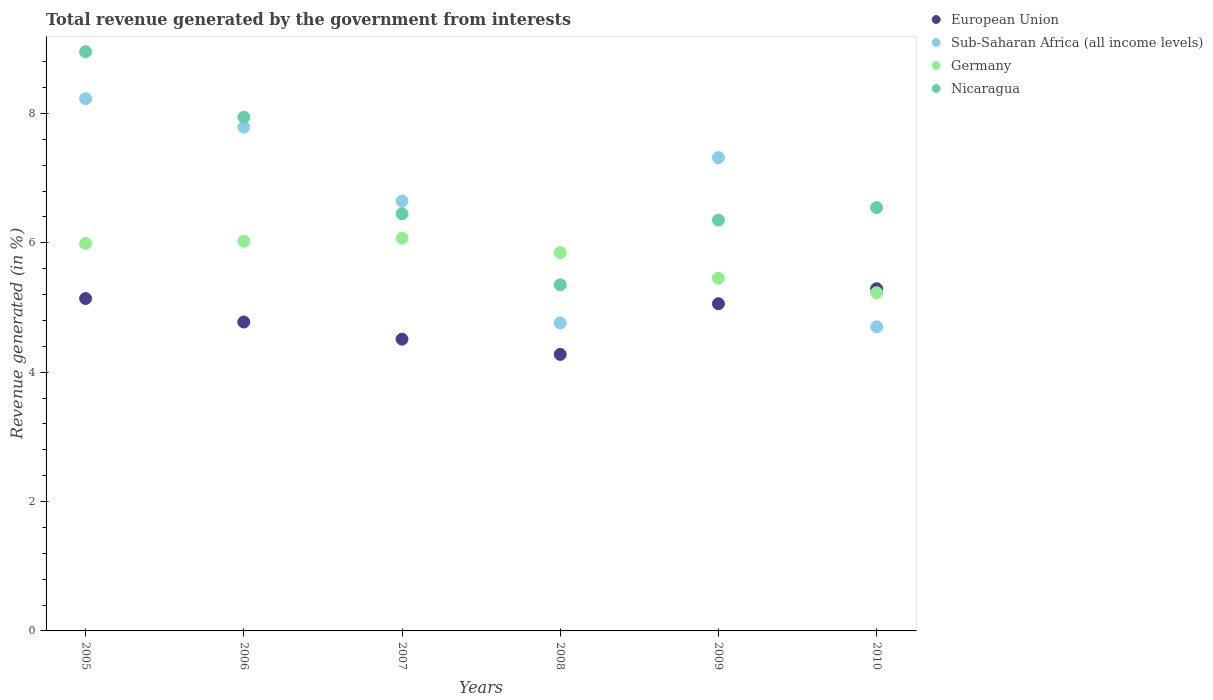How many different coloured dotlines are there?
Make the answer very short. 4. Is the number of dotlines equal to the number of legend labels?
Your response must be concise. Yes. What is the total revenue generated in Sub-Saharan Africa (all income levels) in 2007?
Offer a very short reply. 6.65. Across all years, what is the maximum total revenue generated in Nicaragua?
Provide a succinct answer. 8.96. Across all years, what is the minimum total revenue generated in Germany?
Your response must be concise. 5.23. In which year was the total revenue generated in Sub-Saharan Africa (all income levels) maximum?
Make the answer very short. 2005. In which year was the total revenue generated in Sub-Saharan Africa (all income levels) minimum?
Your answer should be compact. 2010. What is the total total revenue generated in European Union in the graph?
Provide a succinct answer. 29.05. What is the difference between the total revenue generated in Germany in 2005 and that in 2010?
Give a very brief answer. 0.76. What is the difference between the total revenue generated in Germany in 2009 and the total revenue generated in European Union in 2010?
Your answer should be compact. 0.16. What is the average total revenue generated in Sub-Saharan Africa (all income levels) per year?
Make the answer very short. 6.57. In the year 2010, what is the difference between the total revenue generated in Sub-Saharan Africa (all income levels) and total revenue generated in Germany?
Your answer should be compact. -0.53. In how many years, is the total revenue generated in Sub-Saharan Africa (all income levels) greater than 6.8 %?
Give a very brief answer. 3. What is the ratio of the total revenue generated in Sub-Saharan Africa (all income levels) in 2006 to that in 2008?
Provide a succinct answer. 1.64. Is the total revenue generated in European Union in 2005 less than that in 2006?
Your answer should be very brief. No. What is the difference between the highest and the second highest total revenue generated in Germany?
Make the answer very short. 0.05. What is the difference between the highest and the lowest total revenue generated in Germany?
Offer a terse response. 0.84. In how many years, is the total revenue generated in Sub-Saharan Africa (all income levels) greater than the average total revenue generated in Sub-Saharan Africa (all income levels) taken over all years?
Your answer should be very brief. 4. Is the sum of the total revenue generated in Sub-Saharan Africa (all income levels) in 2007 and 2008 greater than the maximum total revenue generated in Nicaragua across all years?
Your answer should be compact. Yes. Is it the case that in every year, the sum of the total revenue generated in Germany and total revenue generated in Sub-Saharan Africa (all income levels)  is greater than the sum of total revenue generated in European Union and total revenue generated in Nicaragua?
Keep it short and to the point. No. Does the total revenue generated in Sub-Saharan Africa (all income levels) monotonically increase over the years?
Offer a terse response. No. How many dotlines are there?
Your answer should be compact. 4. How many years are there in the graph?
Offer a terse response. 6. What is the difference between two consecutive major ticks on the Y-axis?
Keep it short and to the point. 2. Does the graph contain any zero values?
Provide a short and direct response. No. Where does the legend appear in the graph?
Keep it short and to the point. Top right. How many legend labels are there?
Your response must be concise. 4. What is the title of the graph?
Your response must be concise. Total revenue generated by the government from interests. What is the label or title of the Y-axis?
Keep it short and to the point. Revenue generated (in %). What is the Revenue generated (in %) of European Union in 2005?
Offer a very short reply. 5.14. What is the Revenue generated (in %) in Sub-Saharan Africa (all income levels) in 2005?
Make the answer very short. 8.23. What is the Revenue generated (in %) in Germany in 2005?
Provide a short and direct response. 5.99. What is the Revenue generated (in %) of Nicaragua in 2005?
Keep it short and to the point. 8.96. What is the Revenue generated (in %) of European Union in 2006?
Give a very brief answer. 4.78. What is the Revenue generated (in %) of Sub-Saharan Africa (all income levels) in 2006?
Ensure brevity in your answer.  7.79. What is the Revenue generated (in %) of Germany in 2006?
Your response must be concise. 6.03. What is the Revenue generated (in %) in Nicaragua in 2006?
Keep it short and to the point. 7.94. What is the Revenue generated (in %) in European Union in 2007?
Provide a short and direct response. 4.51. What is the Revenue generated (in %) of Sub-Saharan Africa (all income levels) in 2007?
Ensure brevity in your answer.  6.65. What is the Revenue generated (in %) in Germany in 2007?
Provide a short and direct response. 6.07. What is the Revenue generated (in %) in Nicaragua in 2007?
Ensure brevity in your answer.  6.45. What is the Revenue generated (in %) of European Union in 2008?
Provide a succinct answer. 4.28. What is the Revenue generated (in %) in Sub-Saharan Africa (all income levels) in 2008?
Offer a terse response. 4.76. What is the Revenue generated (in %) of Germany in 2008?
Your response must be concise. 5.85. What is the Revenue generated (in %) in Nicaragua in 2008?
Your response must be concise. 5.35. What is the Revenue generated (in %) of European Union in 2009?
Offer a very short reply. 5.06. What is the Revenue generated (in %) in Sub-Saharan Africa (all income levels) in 2009?
Ensure brevity in your answer.  7.32. What is the Revenue generated (in %) of Germany in 2009?
Your answer should be compact. 5.45. What is the Revenue generated (in %) of Nicaragua in 2009?
Keep it short and to the point. 6.35. What is the Revenue generated (in %) of European Union in 2010?
Keep it short and to the point. 5.29. What is the Revenue generated (in %) in Sub-Saharan Africa (all income levels) in 2010?
Offer a very short reply. 4.7. What is the Revenue generated (in %) of Germany in 2010?
Ensure brevity in your answer.  5.23. What is the Revenue generated (in %) in Nicaragua in 2010?
Give a very brief answer. 6.55. Across all years, what is the maximum Revenue generated (in %) in European Union?
Your answer should be very brief. 5.29. Across all years, what is the maximum Revenue generated (in %) in Sub-Saharan Africa (all income levels)?
Provide a succinct answer. 8.23. Across all years, what is the maximum Revenue generated (in %) in Germany?
Offer a terse response. 6.07. Across all years, what is the maximum Revenue generated (in %) of Nicaragua?
Offer a terse response. 8.96. Across all years, what is the minimum Revenue generated (in %) in European Union?
Offer a terse response. 4.28. Across all years, what is the minimum Revenue generated (in %) of Sub-Saharan Africa (all income levels)?
Offer a terse response. 4.7. Across all years, what is the minimum Revenue generated (in %) of Germany?
Provide a succinct answer. 5.23. Across all years, what is the minimum Revenue generated (in %) of Nicaragua?
Make the answer very short. 5.35. What is the total Revenue generated (in %) of European Union in the graph?
Provide a succinct answer. 29.05. What is the total Revenue generated (in %) in Sub-Saharan Africa (all income levels) in the graph?
Offer a terse response. 39.45. What is the total Revenue generated (in %) in Germany in the graph?
Give a very brief answer. 34.62. What is the total Revenue generated (in %) of Nicaragua in the graph?
Offer a terse response. 41.6. What is the difference between the Revenue generated (in %) in European Union in 2005 and that in 2006?
Make the answer very short. 0.36. What is the difference between the Revenue generated (in %) in Sub-Saharan Africa (all income levels) in 2005 and that in 2006?
Your response must be concise. 0.44. What is the difference between the Revenue generated (in %) of Germany in 2005 and that in 2006?
Ensure brevity in your answer.  -0.03. What is the difference between the Revenue generated (in %) in Nicaragua in 2005 and that in 2006?
Keep it short and to the point. 1.01. What is the difference between the Revenue generated (in %) of European Union in 2005 and that in 2007?
Provide a succinct answer. 0.63. What is the difference between the Revenue generated (in %) in Sub-Saharan Africa (all income levels) in 2005 and that in 2007?
Offer a terse response. 1.58. What is the difference between the Revenue generated (in %) in Germany in 2005 and that in 2007?
Offer a terse response. -0.08. What is the difference between the Revenue generated (in %) in Nicaragua in 2005 and that in 2007?
Offer a terse response. 2.5. What is the difference between the Revenue generated (in %) in European Union in 2005 and that in 2008?
Ensure brevity in your answer.  0.86. What is the difference between the Revenue generated (in %) in Sub-Saharan Africa (all income levels) in 2005 and that in 2008?
Provide a short and direct response. 3.47. What is the difference between the Revenue generated (in %) in Germany in 2005 and that in 2008?
Ensure brevity in your answer.  0.14. What is the difference between the Revenue generated (in %) of Nicaragua in 2005 and that in 2008?
Ensure brevity in your answer.  3.6. What is the difference between the Revenue generated (in %) of European Union in 2005 and that in 2009?
Your answer should be very brief. 0.08. What is the difference between the Revenue generated (in %) of Sub-Saharan Africa (all income levels) in 2005 and that in 2009?
Your answer should be compact. 0.91. What is the difference between the Revenue generated (in %) of Germany in 2005 and that in 2009?
Provide a succinct answer. 0.54. What is the difference between the Revenue generated (in %) in Nicaragua in 2005 and that in 2009?
Provide a short and direct response. 2.6. What is the difference between the Revenue generated (in %) of European Union in 2005 and that in 2010?
Keep it short and to the point. -0.15. What is the difference between the Revenue generated (in %) in Sub-Saharan Africa (all income levels) in 2005 and that in 2010?
Provide a short and direct response. 3.53. What is the difference between the Revenue generated (in %) in Germany in 2005 and that in 2010?
Make the answer very short. 0.76. What is the difference between the Revenue generated (in %) in Nicaragua in 2005 and that in 2010?
Offer a very short reply. 2.41. What is the difference between the Revenue generated (in %) in European Union in 2006 and that in 2007?
Offer a terse response. 0.27. What is the difference between the Revenue generated (in %) of Sub-Saharan Africa (all income levels) in 2006 and that in 2007?
Keep it short and to the point. 1.14. What is the difference between the Revenue generated (in %) in Germany in 2006 and that in 2007?
Your answer should be compact. -0.05. What is the difference between the Revenue generated (in %) of Nicaragua in 2006 and that in 2007?
Ensure brevity in your answer.  1.49. What is the difference between the Revenue generated (in %) in European Union in 2006 and that in 2008?
Your response must be concise. 0.5. What is the difference between the Revenue generated (in %) in Sub-Saharan Africa (all income levels) in 2006 and that in 2008?
Provide a short and direct response. 3.03. What is the difference between the Revenue generated (in %) in Germany in 2006 and that in 2008?
Offer a terse response. 0.18. What is the difference between the Revenue generated (in %) of Nicaragua in 2006 and that in 2008?
Give a very brief answer. 2.59. What is the difference between the Revenue generated (in %) of European Union in 2006 and that in 2009?
Provide a short and direct response. -0.28. What is the difference between the Revenue generated (in %) of Sub-Saharan Africa (all income levels) in 2006 and that in 2009?
Keep it short and to the point. 0.47. What is the difference between the Revenue generated (in %) in Germany in 2006 and that in 2009?
Your response must be concise. 0.57. What is the difference between the Revenue generated (in %) of Nicaragua in 2006 and that in 2009?
Provide a short and direct response. 1.59. What is the difference between the Revenue generated (in %) in European Union in 2006 and that in 2010?
Give a very brief answer. -0.51. What is the difference between the Revenue generated (in %) in Sub-Saharan Africa (all income levels) in 2006 and that in 2010?
Offer a terse response. 3.09. What is the difference between the Revenue generated (in %) in Germany in 2006 and that in 2010?
Offer a terse response. 0.8. What is the difference between the Revenue generated (in %) of Nicaragua in 2006 and that in 2010?
Offer a very short reply. 1.4. What is the difference between the Revenue generated (in %) of European Union in 2007 and that in 2008?
Make the answer very short. 0.24. What is the difference between the Revenue generated (in %) of Sub-Saharan Africa (all income levels) in 2007 and that in 2008?
Keep it short and to the point. 1.88. What is the difference between the Revenue generated (in %) of Germany in 2007 and that in 2008?
Your answer should be very brief. 0.22. What is the difference between the Revenue generated (in %) in Nicaragua in 2007 and that in 2008?
Your answer should be very brief. 1.1. What is the difference between the Revenue generated (in %) in European Union in 2007 and that in 2009?
Ensure brevity in your answer.  -0.55. What is the difference between the Revenue generated (in %) in Sub-Saharan Africa (all income levels) in 2007 and that in 2009?
Provide a short and direct response. -0.67. What is the difference between the Revenue generated (in %) of Germany in 2007 and that in 2009?
Your response must be concise. 0.62. What is the difference between the Revenue generated (in %) in Nicaragua in 2007 and that in 2009?
Keep it short and to the point. 0.1. What is the difference between the Revenue generated (in %) of European Union in 2007 and that in 2010?
Your answer should be compact. -0.78. What is the difference between the Revenue generated (in %) in Sub-Saharan Africa (all income levels) in 2007 and that in 2010?
Your answer should be compact. 1.95. What is the difference between the Revenue generated (in %) in Germany in 2007 and that in 2010?
Give a very brief answer. 0.84. What is the difference between the Revenue generated (in %) of Nicaragua in 2007 and that in 2010?
Make the answer very short. -0.1. What is the difference between the Revenue generated (in %) in European Union in 2008 and that in 2009?
Give a very brief answer. -0.78. What is the difference between the Revenue generated (in %) in Sub-Saharan Africa (all income levels) in 2008 and that in 2009?
Your answer should be very brief. -2.56. What is the difference between the Revenue generated (in %) in Germany in 2008 and that in 2009?
Your answer should be very brief. 0.4. What is the difference between the Revenue generated (in %) in Nicaragua in 2008 and that in 2009?
Make the answer very short. -1. What is the difference between the Revenue generated (in %) of European Union in 2008 and that in 2010?
Keep it short and to the point. -1.01. What is the difference between the Revenue generated (in %) of Sub-Saharan Africa (all income levels) in 2008 and that in 2010?
Offer a terse response. 0.06. What is the difference between the Revenue generated (in %) in Germany in 2008 and that in 2010?
Make the answer very short. 0.62. What is the difference between the Revenue generated (in %) in Nicaragua in 2008 and that in 2010?
Provide a succinct answer. -1.19. What is the difference between the Revenue generated (in %) in European Union in 2009 and that in 2010?
Provide a short and direct response. -0.23. What is the difference between the Revenue generated (in %) of Sub-Saharan Africa (all income levels) in 2009 and that in 2010?
Provide a short and direct response. 2.62. What is the difference between the Revenue generated (in %) in Germany in 2009 and that in 2010?
Offer a terse response. 0.22. What is the difference between the Revenue generated (in %) in Nicaragua in 2009 and that in 2010?
Offer a very short reply. -0.19. What is the difference between the Revenue generated (in %) of European Union in 2005 and the Revenue generated (in %) of Sub-Saharan Africa (all income levels) in 2006?
Keep it short and to the point. -2.65. What is the difference between the Revenue generated (in %) of European Union in 2005 and the Revenue generated (in %) of Germany in 2006?
Your answer should be compact. -0.89. What is the difference between the Revenue generated (in %) of European Union in 2005 and the Revenue generated (in %) of Nicaragua in 2006?
Provide a succinct answer. -2.8. What is the difference between the Revenue generated (in %) of Sub-Saharan Africa (all income levels) in 2005 and the Revenue generated (in %) of Germany in 2006?
Ensure brevity in your answer.  2.2. What is the difference between the Revenue generated (in %) of Sub-Saharan Africa (all income levels) in 2005 and the Revenue generated (in %) of Nicaragua in 2006?
Make the answer very short. 0.29. What is the difference between the Revenue generated (in %) of Germany in 2005 and the Revenue generated (in %) of Nicaragua in 2006?
Your answer should be compact. -1.95. What is the difference between the Revenue generated (in %) in European Union in 2005 and the Revenue generated (in %) in Sub-Saharan Africa (all income levels) in 2007?
Your answer should be compact. -1.51. What is the difference between the Revenue generated (in %) in European Union in 2005 and the Revenue generated (in %) in Germany in 2007?
Keep it short and to the point. -0.93. What is the difference between the Revenue generated (in %) of European Union in 2005 and the Revenue generated (in %) of Nicaragua in 2007?
Provide a short and direct response. -1.31. What is the difference between the Revenue generated (in %) of Sub-Saharan Africa (all income levels) in 2005 and the Revenue generated (in %) of Germany in 2007?
Make the answer very short. 2.16. What is the difference between the Revenue generated (in %) of Sub-Saharan Africa (all income levels) in 2005 and the Revenue generated (in %) of Nicaragua in 2007?
Offer a very short reply. 1.78. What is the difference between the Revenue generated (in %) in Germany in 2005 and the Revenue generated (in %) in Nicaragua in 2007?
Offer a very short reply. -0.46. What is the difference between the Revenue generated (in %) of European Union in 2005 and the Revenue generated (in %) of Sub-Saharan Africa (all income levels) in 2008?
Offer a terse response. 0.38. What is the difference between the Revenue generated (in %) of European Union in 2005 and the Revenue generated (in %) of Germany in 2008?
Offer a terse response. -0.71. What is the difference between the Revenue generated (in %) in European Union in 2005 and the Revenue generated (in %) in Nicaragua in 2008?
Ensure brevity in your answer.  -0.21. What is the difference between the Revenue generated (in %) of Sub-Saharan Africa (all income levels) in 2005 and the Revenue generated (in %) of Germany in 2008?
Make the answer very short. 2.38. What is the difference between the Revenue generated (in %) in Sub-Saharan Africa (all income levels) in 2005 and the Revenue generated (in %) in Nicaragua in 2008?
Provide a short and direct response. 2.88. What is the difference between the Revenue generated (in %) of Germany in 2005 and the Revenue generated (in %) of Nicaragua in 2008?
Offer a very short reply. 0.64. What is the difference between the Revenue generated (in %) in European Union in 2005 and the Revenue generated (in %) in Sub-Saharan Africa (all income levels) in 2009?
Make the answer very short. -2.18. What is the difference between the Revenue generated (in %) of European Union in 2005 and the Revenue generated (in %) of Germany in 2009?
Your answer should be compact. -0.31. What is the difference between the Revenue generated (in %) of European Union in 2005 and the Revenue generated (in %) of Nicaragua in 2009?
Offer a very short reply. -1.21. What is the difference between the Revenue generated (in %) in Sub-Saharan Africa (all income levels) in 2005 and the Revenue generated (in %) in Germany in 2009?
Offer a very short reply. 2.78. What is the difference between the Revenue generated (in %) of Sub-Saharan Africa (all income levels) in 2005 and the Revenue generated (in %) of Nicaragua in 2009?
Make the answer very short. 1.88. What is the difference between the Revenue generated (in %) of Germany in 2005 and the Revenue generated (in %) of Nicaragua in 2009?
Offer a terse response. -0.36. What is the difference between the Revenue generated (in %) in European Union in 2005 and the Revenue generated (in %) in Sub-Saharan Africa (all income levels) in 2010?
Provide a succinct answer. 0.44. What is the difference between the Revenue generated (in %) of European Union in 2005 and the Revenue generated (in %) of Germany in 2010?
Ensure brevity in your answer.  -0.09. What is the difference between the Revenue generated (in %) of European Union in 2005 and the Revenue generated (in %) of Nicaragua in 2010?
Provide a succinct answer. -1.41. What is the difference between the Revenue generated (in %) of Sub-Saharan Africa (all income levels) in 2005 and the Revenue generated (in %) of Germany in 2010?
Keep it short and to the point. 3. What is the difference between the Revenue generated (in %) in Sub-Saharan Africa (all income levels) in 2005 and the Revenue generated (in %) in Nicaragua in 2010?
Provide a succinct answer. 1.68. What is the difference between the Revenue generated (in %) in Germany in 2005 and the Revenue generated (in %) in Nicaragua in 2010?
Your response must be concise. -0.56. What is the difference between the Revenue generated (in %) of European Union in 2006 and the Revenue generated (in %) of Sub-Saharan Africa (all income levels) in 2007?
Provide a short and direct response. -1.87. What is the difference between the Revenue generated (in %) of European Union in 2006 and the Revenue generated (in %) of Germany in 2007?
Keep it short and to the point. -1.3. What is the difference between the Revenue generated (in %) in European Union in 2006 and the Revenue generated (in %) in Nicaragua in 2007?
Offer a very short reply. -1.67. What is the difference between the Revenue generated (in %) in Sub-Saharan Africa (all income levels) in 2006 and the Revenue generated (in %) in Germany in 2007?
Provide a succinct answer. 1.72. What is the difference between the Revenue generated (in %) of Sub-Saharan Africa (all income levels) in 2006 and the Revenue generated (in %) of Nicaragua in 2007?
Your answer should be compact. 1.34. What is the difference between the Revenue generated (in %) in Germany in 2006 and the Revenue generated (in %) in Nicaragua in 2007?
Make the answer very short. -0.43. What is the difference between the Revenue generated (in %) in European Union in 2006 and the Revenue generated (in %) in Sub-Saharan Africa (all income levels) in 2008?
Make the answer very short. 0.01. What is the difference between the Revenue generated (in %) of European Union in 2006 and the Revenue generated (in %) of Germany in 2008?
Give a very brief answer. -1.07. What is the difference between the Revenue generated (in %) of European Union in 2006 and the Revenue generated (in %) of Nicaragua in 2008?
Make the answer very short. -0.58. What is the difference between the Revenue generated (in %) of Sub-Saharan Africa (all income levels) in 2006 and the Revenue generated (in %) of Germany in 2008?
Your answer should be very brief. 1.94. What is the difference between the Revenue generated (in %) in Sub-Saharan Africa (all income levels) in 2006 and the Revenue generated (in %) in Nicaragua in 2008?
Keep it short and to the point. 2.44. What is the difference between the Revenue generated (in %) in Germany in 2006 and the Revenue generated (in %) in Nicaragua in 2008?
Offer a terse response. 0.67. What is the difference between the Revenue generated (in %) of European Union in 2006 and the Revenue generated (in %) of Sub-Saharan Africa (all income levels) in 2009?
Your answer should be compact. -2.54. What is the difference between the Revenue generated (in %) of European Union in 2006 and the Revenue generated (in %) of Germany in 2009?
Offer a very short reply. -0.68. What is the difference between the Revenue generated (in %) in European Union in 2006 and the Revenue generated (in %) in Nicaragua in 2009?
Give a very brief answer. -1.58. What is the difference between the Revenue generated (in %) in Sub-Saharan Africa (all income levels) in 2006 and the Revenue generated (in %) in Germany in 2009?
Provide a short and direct response. 2.33. What is the difference between the Revenue generated (in %) in Sub-Saharan Africa (all income levels) in 2006 and the Revenue generated (in %) in Nicaragua in 2009?
Ensure brevity in your answer.  1.44. What is the difference between the Revenue generated (in %) of Germany in 2006 and the Revenue generated (in %) of Nicaragua in 2009?
Your answer should be very brief. -0.33. What is the difference between the Revenue generated (in %) of European Union in 2006 and the Revenue generated (in %) of Sub-Saharan Africa (all income levels) in 2010?
Your response must be concise. 0.07. What is the difference between the Revenue generated (in %) of European Union in 2006 and the Revenue generated (in %) of Germany in 2010?
Give a very brief answer. -0.45. What is the difference between the Revenue generated (in %) of European Union in 2006 and the Revenue generated (in %) of Nicaragua in 2010?
Your response must be concise. -1.77. What is the difference between the Revenue generated (in %) in Sub-Saharan Africa (all income levels) in 2006 and the Revenue generated (in %) in Germany in 2010?
Offer a terse response. 2.56. What is the difference between the Revenue generated (in %) in Sub-Saharan Africa (all income levels) in 2006 and the Revenue generated (in %) in Nicaragua in 2010?
Offer a terse response. 1.24. What is the difference between the Revenue generated (in %) of Germany in 2006 and the Revenue generated (in %) of Nicaragua in 2010?
Offer a very short reply. -0.52. What is the difference between the Revenue generated (in %) in European Union in 2007 and the Revenue generated (in %) in Sub-Saharan Africa (all income levels) in 2008?
Provide a short and direct response. -0.25. What is the difference between the Revenue generated (in %) in European Union in 2007 and the Revenue generated (in %) in Germany in 2008?
Make the answer very short. -1.34. What is the difference between the Revenue generated (in %) of European Union in 2007 and the Revenue generated (in %) of Nicaragua in 2008?
Ensure brevity in your answer.  -0.84. What is the difference between the Revenue generated (in %) in Sub-Saharan Africa (all income levels) in 2007 and the Revenue generated (in %) in Germany in 2008?
Give a very brief answer. 0.8. What is the difference between the Revenue generated (in %) in Sub-Saharan Africa (all income levels) in 2007 and the Revenue generated (in %) in Nicaragua in 2008?
Ensure brevity in your answer.  1.29. What is the difference between the Revenue generated (in %) of Germany in 2007 and the Revenue generated (in %) of Nicaragua in 2008?
Make the answer very short. 0.72. What is the difference between the Revenue generated (in %) in European Union in 2007 and the Revenue generated (in %) in Sub-Saharan Africa (all income levels) in 2009?
Your answer should be compact. -2.81. What is the difference between the Revenue generated (in %) in European Union in 2007 and the Revenue generated (in %) in Germany in 2009?
Ensure brevity in your answer.  -0.94. What is the difference between the Revenue generated (in %) of European Union in 2007 and the Revenue generated (in %) of Nicaragua in 2009?
Give a very brief answer. -1.84. What is the difference between the Revenue generated (in %) in Sub-Saharan Africa (all income levels) in 2007 and the Revenue generated (in %) in Germany in 2009?
Offer a very short reply. 1.19. What is the difference between the Revenue generated (in %) in Sub-Saharan Africa (all income levels) in 2007 and the Revenue generated (in %) in Nicaragua in 2009?
Provide a short and direct response. 0.29. What is the difference between the Revenue generated (in %) of Germany in 2007 and the Revenue generated (in %) of Nicaragua in 2009?
Make the answer very short. -0.28. What is the difference between the Revenue generated (in %) in European Union in 2007 and the Revenue generated (in %) in Sub-Saharan Africa (all income levels) in 2010?
Your answer should be compact. -0.19. What is the difference between the Revenue generated (in %) of European Union in 2007 and the Revenue generated (in %) of Germany in 2010?
Keep it short and to the point. -0.72. What is the difference between the Revenue generated (in %) in European Union in 2007 and the Revenue generated (in %) in Nicaragua in 2010?
Offer a very short reply. -2.04. What is the difference between the Revenue generated (in %) in Sub-Saharan Africa (all income levels) in 2007 and the Revenue generated (in %) in Germany in 2010?
Provide a succinct answer. 1.42. What is the difference between the Revenue generated (in %) in Sub-Saharan Africa (all income levels) in 2007 and the Revenue generated (in %) in Nicaragua in 2010?
Make the answer very short. 0.1. What is the difference between the Revenue generated (in %) of Germany in 2007 and the Revenue generated (in %) of Nicaragua in 2010?
Your answer should be very brief. -0.47. What is the difference between the Revenue generated (in %) in European Union in 2008 and the Revenue generated (in %) in Sub-Saharan Africa (all income levels) in 2009?
Your response must be concise. -3.04. What is the difference between the Revenue generated (in %) in European Union in 2008 and the Revenue generated (in %) in Germany in 2009?
Provide a succinct answer. -1.18. What is the difference between the Revenue generated (in %) of European Union in 2008 and the Revenue generated (in %) of Nicaragua in 2009?
Provide a succinct answer. -2.08. What is the difference between the Revenue generated (in %) in Sub-Saharan Africa (all income levels) in 2008 and the Revenue generated (in %) in Germany in 2009?
Make the answer very short. -0.69. What is the difference between the Revenue generated (in %) in Sub-Saharan Africa (all income levels) in 2008 and the Revenue generated (in %) in Nicaragua in 2009?
Provide a succinct answer. -1.59. What is the difference between the Revenue generated (in %) in Germany in 2008 and the Revenue generated (in %) in Nicaragua in 2009?
Offer a very short reply. -0.5. What is the difference between the Revenue generated (in %) in European Union in 2008 and the Revenue generated (in %) in Sub-Saharan Africa (all income levels) in 2010?
Offer a very short reply. -0.43. What is the difference between the Revenue generated (in %) of European Union in 2008 and the Revenue generated (in %) of Germany in 2010?
Provide a short and direct response. -0.95. What is the difference between the Revenue generated (in %) of European Union in 2008 and the Revenue generated (in %) of Nicaragua in 2010?
Ensure brevity in your answer.  -2.27. What is the difference between the Revenue generated (in %) of Sub-Saharan Africa (all income levels) in 2008 and the Revenue generated (in %) of Germany in 2010?
Keep it short and to the point. -0.47. What is the difference between the Revenue generated (in %) of Sub-Saharan Africa (all income levels) in 2008 and the Revenue generated (in %) of Nicaragua in 2010?
Provide a succinct answer. -1.78. What is the difference between the Revenue generated (in %) in Germany in 2008 and the Revenue generated (in %) in Nicaragua in 2010?
Your answer should be very brief. -0.7. What is the difference between the Revenue generated (in %) in European Union in 2009 and the Revenue generated (in %) in Sub-Saharan Africa (all income levels) in 2010?
Provide a short and direct response. 0.36. What is the difference between the Revenue generated (in %) of European Union in 2009 and the Revenue generated (in %) of Germany in 2010?
Give a very brief answer. -0.17. What is the difference between the Revenue generated (in %) of European Union in 2009 and the Revenue generated (in %) of Nicaragua in 2010?
Your answer should be compact. -1.49. What is the difference between the Revenue generated (in %) of Sub-Saharan Africa (all income levels) in 2009 and the Revenue generated (in %) of Germany in 2010?
Offer a terse response. 2.09. What is the difference between the Revenue generated (in %) in Sub-Saharan Africa (all income levels) in 2009 and the Revenue generated (in %) in Nicaragua in 2010?
Keep it short and to the point. 0.77. What is the difference between the Revenue generated (in %) of Germany in 2009 and the Revenue generated (in %) of Nicaragua in 2010?
Ensure brevity in your answer.  -1.09. What is the average Revenue generated (in %) of European Union per year?
Provide a succinct answer. 4.84. What is the average Revenue generated (in %) in Sub-Saharan Africa (all income levels) per year?
Ensure brevity in your answer.  6.57. What is the average Revenue generated (in %) in Germany per year?
Your answer should be compact. 5.77. What is the average Revenue generated (in %) of Nicaragua per year?
Keep it short and to the point. 6.93. In the year 2005, what is the difference between the Revenue generated (in %) of European Union and Revenue generated (in %) of Sub-Saharan Africa (all income levels)?
Ensure brevity in your answer.  -3.09. In the year 2005, what is the difference between the Revenue generated (in %) of European Union and Revenue generated (in %) of Germany?
Provide a succinct answer. -0.85. In the year 2005, what is the difference between the Revenue generated (in %) of European Union and Revenue generated (in %) of Nicaragua?
Your answer should be very brief. -3.82. In the year 2005, what is the difference between the Revenue generated (in %) in Sub-Saharan Africa (all income levels) and Revenue generated (in %) in Germany?
Your response must be concise. 2.24. In the year 2005, what is the difference between the Revenue generated (in %) in Sub-Saharan Africa (all income levels) and Revenue generated (in %) in Nicaragua?
Offer a terse response. -0.73. In the year 2005, what is the difference between the Revenue generated (in %) of Germany and Revenue generated (in %) of Nicaragua?
Ensure brevity in your answer.  -2.96. In the year 2006, what is the difference between the Revenue generated (in %) of European Union and Revenue generated (in %) of Sub-Saharan Africa (all income levels)?
Offer a very short reply. -3.01. In the year 2006, what is the difference between the Revenue generated (in %) of European Union and Revenue generated (in %) of Germany?
Provide a short and direct response. -1.25. In the year 2006, what is the difference between the Revenue generated (in %) of European Union and Revenue generated (in %) of Nicaragua?
Offer a very short reply. -3.17. In the year 2006, what is the difference between the Revenue generated (in %) in Sub-Saharan Africa (all income levels) and Revenue generated (in %) in Germany?
Provide a short and direct response. 1.76. In the year 2006, what is the difference between the Revenue generated (in %) of Sub-Saharan Africa (all income levels) and Revenue generated (in %) of Nicaragua?
Make the answer very short. -0.15. In the year 2006, what is the difference between the Revenue generated (in %) of Germany and Revenue generated (in %) of Nicaragua?
Your answer should be compact. -1.92. In the year 2007, what is the difference between the Revenue generated (in %) of European Union and Revenue generated (in %) of Sub-Saharan Africa (all income levels)?
Provide a succinct answer. -2.14. In the year 2007, what is the difference between the Revenue generated (in %) of European Union and Revenue generated (in %) of Germany?
Provide a short and direct response. -1.56. In the year 2007, what is the difference between the Revenue generated (in %) in European Union and Revenue generated (in %) in Nicaragua?
Provide a succinct answer. -1.94. In the year 2007, what is the difference between the Revenue generated (in %) in Sub-Saharan Africa (all income levels) and Revenue generated (in %) in Germany?
Give a very brief answer. 0.57. In the year 2007, what is the difference between the Revenue generated (in %) of Sub-Saharan Africa (all income levels) and Revenue generated (in %) of Nicaragua?
Offer a very short reply. 0.2. In the year 2007, what is the difference between the Revenue generated (in %) in Germany and Revenue generated (in %) in Nicaragua?
Your response must be concise. -0.38. In the year 2008, what is the difference between the Revenue generated (in %) of European Union and Revenue generated (in %) of Sub-Saharan Africa (all income levels)?
Offer a very short reply. -0.49. In the year 2008, what is the difference between the Revenue generated (in %) in European Union and Revenue generated (in %) in Germany?
Your answer should be compact. -1.57. In the year 2008, what is the difference between the Revenue generated (in %) in European Union and Revenue generated (in %) in Nicaragua?
Offer a terse response. -1.08. In the year 2008, what is the difference between the Revenue generated (in %) in Sub-Saharan Africa (all income levels) and Revenue generated (in %) in Germany?
Offer a terse response. -1.09. In the year 2008, what is the difference between the Revenue generated (in %) in Sub-Saharan Africa (all income levels) and Revenue generated (in %) in Nicaragua?
Provide a short and direct response. -0.59. In the year 2008, what is the difference between the Revenue generated (in %) of Germany and Revenue generated (in %) of Nicaragua?
Give a very brief answer. 0.5. In the year 2009, what is the difference between the Revenue generated (in %) of European Union and Revenue generated (in %) of Sub-Saharan Africa (all income levels)?
Give a very brief answer. -2.26. In the year 2009, what is the difference between the Revenue generated (in %) in European Union and Revenue generated (in %) in Germany?
Provide a succinct answer. -0.39. In the year 2009, what is the difference between the Revenue generated (in %) in European Union and Revenue generated (in %) in Nicaragua?
Offer a very short reply. -1.29. In the year 2009, what is the difference between the Revenue generated (in %) of Sub-Saharan Africa (all income levels) and Revenue generated (in %) of Germany?
Provide a succinct answer. 1.86. In the year 2009, what is the difference between the Revenue generated (in %) in Sub-Saharan Africa (all income levels) and Revenue generated (in %) in Nicaragua?
Your answer should be very brief. 0.97. In the year 2009, what is the difference between the Revenue generated (in %) in Germany and Revenue generated (in %) in Nicaragua?
Give a very brief answer. -0.9. In the year 2010, what is the difference between the Revenue generated (in %) in European Union and Revenue generated (in %) in Sub-Saharan Africa (all income levels)?
Offer a very short reply. 0.59. In the year 2010, what is the difference between the Revenue generated (in %) of European Union and Revenue generated (in %) of Germany?
Ensure brevity in your answer.  0.06. In the year 2010, what is the difference between the Revenue generated (in %) in European Union and Revenue generated (in %) in Nicaragua?
Offer a terse response. -1.26. In the year 2010, what is the difference between the Revenue generated (in %) of Sub-Saharan Africa (all income levels) and Revenue generated (in %) of Germany?
Give a very brief answer. -0.53. In the year 2010, what is the difference between the Revenue generated (in %) in Sub-Saharan Africa (all income levels) and Revenue generated (in %) in Nicaragua?
Give a very brief answer. -1.84. In the year 2010, what is the difference between the Revenue generated (in %) of Germany and Revenue generated (in %) of Nicaragua?
Provide a short and direct response. -1.32. What is the ratio of the Revenue generated (in %) of European Union in 2005 to that in 2006?
Keep it short and to the point. 1.08. What is the ratio of the Revenue generated (in %) of Sub-Saharan Africa (all income levels) in 2005 to that in 2006?
Provide a succinct answer. 1.06. What is the ratio of the Revenue generated (in %) in Germany in 2005 to that in 2006?
Ensure brevity in your answer.  0.99. What is the ratio of the Revenue generated (in %) of Nicaragua in 2005 to that in 2006?
Offer a very short reply. 1.13. What is the ratio of the Revenue generated (in %) in European Union in 2005 to that in 2007?
Your answer should be compact. 1.14. What is the ratio of the Revenue generated (in %) of Sub-Saharan Africa (all income levels) in 2005 to that in 2007?
Offer a terse response. 1.24. What is the ratio of the Revenue generated (in %) in Germany in 2005 to that in 2007?
Make the answer very short. 0.99. What is the ratio of the Revenue generated (in %) of Nicaragua in 2005 to that in 2007?
Your answer should be very brief. 1.39. What is the ratio of the Revenue generated (in %) in European Union in 2005 to that in 2008?
Your response must be concise. 1.2. What is the ratio of the Revenue generated (in %) in Sub-Saharan Africa (all income levels) in 2005 to that in 2008?
Your response must be concise. 1.73. What is the ratio of the Revenue generated (in %) of Germany in 2005 to that in 2008?
Your answer should be compact. 1.02. What is the ratio of the Revenue generated (in %) of Nicaragua in 2005 to that in 2008?
Provide a succinct answer. 1.67. What is the ratio of the Revenue generated (in %) of European Union in 2005 to that in 2009?
Provide a short and direct response. 1.02. What is the ratio of the Revenue generated (in %) of Sub-Saharan Africa (all income levels) in 2005 to that in 2009?
Offer a terse response. 1.12. What is the ratio of the Revenue generated (in %) in Germany in 2005 to that in 2009?
Your answer should be very brief. 1.1. What is the ratio of the Revenue generated (in %) of Nicaragua in 2005 to that in 2009?
Make the answer very short. 1.41. What is the ratio of the Revenue generated (in %) of European Union in 2005 to that in 2010?
Make the answer very short. 0.97. What is the ratio of the Revenue generated (in %) of Sub-Saharan Africa (all income levels) in 2005 to that in 2010?
Make the answer very short. 1.75. What is the ratio of the Revenue generated (in %) of Germany in 2005 to that in 2010?
Offer a terse response. 1.15. What is the ratio of the Revenue generated (in %) in Nicaragua in 2005 to that in 2010?
Offer a very short reply. 1.37. What is the ratio of the Revenue generated (in %) of European Union in 2006 to that in 2007?
Your answer should be compact. 1.06. What is the ratio of the Revenue generated (in %) of Sub-Saharan Africa (all income levels) in 2006 to that in 2007?
Your answer should be very brief. 1.17. What is the ratio of the Revenue generated (in %) of Nicaragua in 2006 to that in 2007?
Keep it short and to the point. 1.23. What is the ratio of the Revenue generated (in %) in European Union in 2006 to that in 2008?
Give a very brief answer. 1.12. What is the ratio of the Revenue generated (in %) of Sub-Saharan Africa (all income levels) in 2006 to that in 2008?
Your response must be concise. 1.64. What is the ratio of the Revenue generated (in %) in Germany in 2006 to that in 2008?
Offer a terse response. 1.03. What is the ratio of the Revenue generated (in %) in Nicaragua in 2006 to that in 2008?
Ensure brevity in your answer.  1.48. What is the ratio of the Revenue generated (in %) in European Union in 2006 to that in 2009?
Keep it short and to the point. 0.94. What is the ratio of the Revenue generated (in %) in Sub-Saharan Africa (all income levels) in 2006 to that in 2009?
Offer a very short reply. 1.06. What is the ratio of the Revenue generated (in %) of Germany in 2006 to that in 2009?
Offer a very short reply. 1.1. What is the ratio of the Revenue generated (in %) in Nicaragua in 2006 to that in 2009?
Give a very brief answer. 1.25. What is the ratio of the Revenue generated (in %) in European Union in 2006 to that in 2010?
Your answer should be compact. 0.9. What is the ratio of the Revenue generated (in %) of Sub-Saharan Africa (all income levels) in 2006 to that in 2010?
Ensure brevity in your answer.  1.66. What is the ratio of the Revenue generated (in %) of Germany in 2006 to that in 2010?
Give a very brief answer. 1.15. What is the ratio of the Revenue generated (in %) of Nicaragua in 2006 to that in 2010?
Provide a succinct answer. 1.21. What is the ratio of the Revenue generated (in %) of European Union in 2007 to that in 2008?
Keep it short and to the point. 1.06. What is the ratio of the Revenue generated (in %) of Sub-Saharan Africa (all income levels) in 2007 to that in 2008?
Provide a succinct answer. 1.4. What is the ratio of the Revenue generated (in %) of Germany in 2007 to that in 2008?
Provide a succinct answer. 1.04. What is the ratio of the Revenue generated (in %) of Nicaragua in 2007 to that in 2008?
Provide a succinct answer. 1.21. What is the ratio of the Revenue generated (in %) of European Union in 2007 to that in 2009?
Provide a short and direct response. 0.89. What is the ratio of the Revenue generated (in %) of Sub-Saharan Africa (all income levels) in 2007 to that in 2009?
Ensure brevity in your answer.  0.91. What is the ratio of the Revenue generated (in %) of Germany in 2007 to that in 2009?
Keep it short and to the point. 1.11. What is the ratio of the Revenue generated (in %) of Nicaragua in 2007 to that in 2009?
Offer a very short reply. 1.02. What is the ratio of the Revenue generated (in %) of European Union in 2007 to that in 2010?
Your response must be concise. 0.85. What is the ratio of the Revenue generated (in %) in Sub-Saharan Africa (all income levels) in 2007 to that in 2010?
Offer a very short reply. 1.41. What is the ratio of the Revenue generated (in %) in Germany in 2007 to that in 2010?
Ensure brevity in your answer.  1.16. What is the ratio of the Revenue generated (in %) of Nicaragua in 2007 to that in 2010?
Provide a succinct answer. 0.99. What is the ratio of the Revenue generated (in %) of European Union in 2008 to that in 2009?
Provide a succinct answer. 0.84. What is the ratio of the Revenue generated (in %) in Sub-Saharan Africa (all income levels) in 2008 to that in 2009?
Your answer should be very brief. 0.65. What is the ratio of the Revenue generated (in %) in Germany in 2008 to that in 2009?
Give a very brief answer. 1.07. What is the ratio of the Revenue generated (in %) of Nicaragua in 2008 to that in 2009?
Keep it short and to the point. 0.84. What is the ratio of the Revenue generated (in %) of European Union in 2008 to that in 2010?
Ensure brevity in your answer.  0.81. What is the ratio of the Revenue generated (in %) of Sub-Saharan Africa (all income levels) in 2008 to that in 2010?
Offer a very short reply. 1.01. What is the ratio of the Revenue generated (in %) of Germany in 2008 to that in 2010?
Your response must be concise. 1.12. What is the ratio of the Revenue generated (in %) of Nicaragua in 2008 to that in 2010?
Provide a short and direct response. 0.82. What is the ratio of the Revenue generated (in %) in European Union in 2009 to that in 2010?
Provide a succinct answer. 0.96. What is the ratio of the Revenue generated (in %) of Sub-Saharan Africa (all income levels) in 2009 to that in 2010?
Offer a very short reply. 1.56. What is the ratio of the Revenue generated (in %) in Germany in 2009 to that in 2010?
Keep it short and to the point. 1.04. What is the ratio of the Revenue generated (in %) of Nicaragua in 2009 to that in 2010?
Your response must be concise. 0.97. What is the difference between the highest and the second highest Revenue generated (in %) of European Union?
Your response must be concise. 0.15. What is the difference between the highest and the second highest Revenue generated (in %) of Sub-Saharan Africa (all income levels)?
Offer a very short reply. 0.44. What is the difference between the highest and the second highest Revenue generated (in %) in Germany?
Offer a very short reply. 0.05. What is the difference between the highest and the second highest Revenue generated (in %) of Nicaragua?
Keep it short and to the point. 1.01. What is the difference between the highest and the lowest Revenue generated (in %) of Sub-Saharan Africa (all income levels)?
Your answer should be compact. 3.53. What is the difference between the highest and the lowest Revenue generated (in %) of Germany?
Your answer should be very brief. 0.84. What is the difference between the highest and the lowest Revenue generated (in %) of Nicaragua?
Make the answer very short. 3.6. 